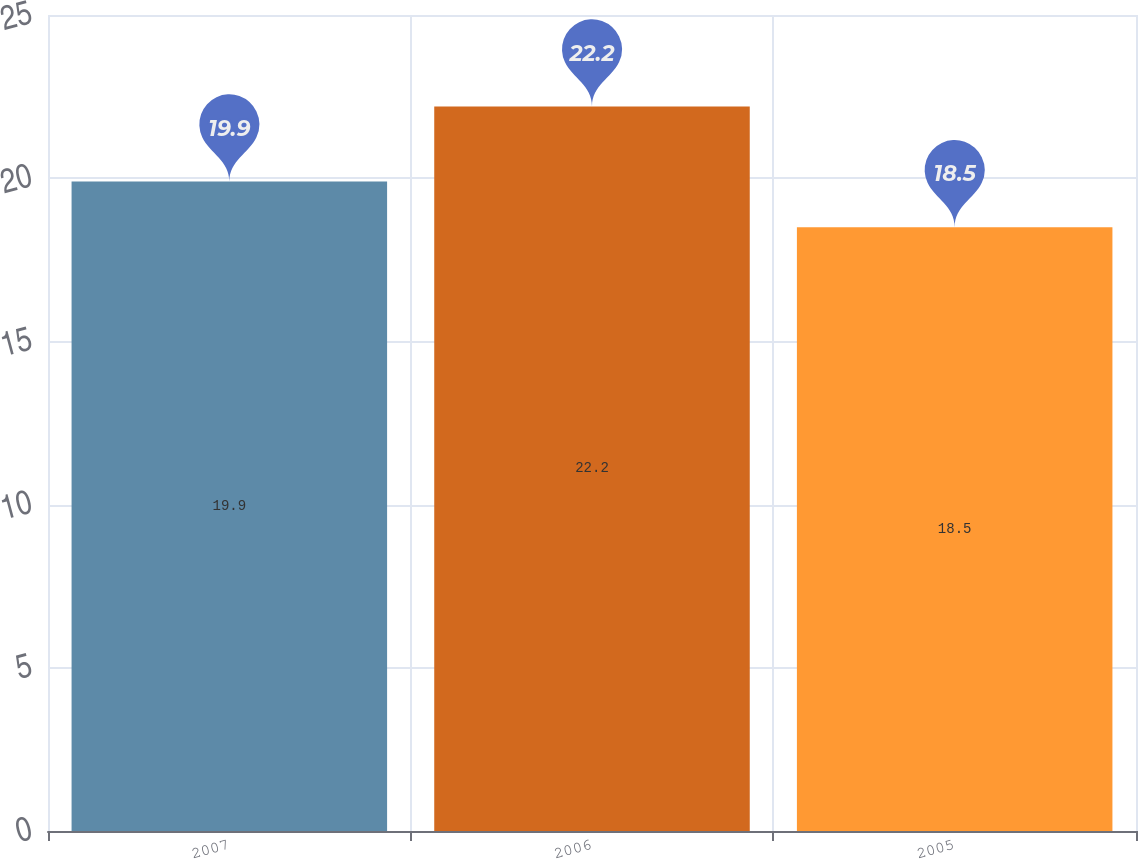<chart> <loc_0><loc_0><loc_500><loc_500><bar_chart><fcel>2007<fcel>2006<fcel>2005<nl><fcel>19.9<fcel>22.2<fcel>18.5<nl></chart> 